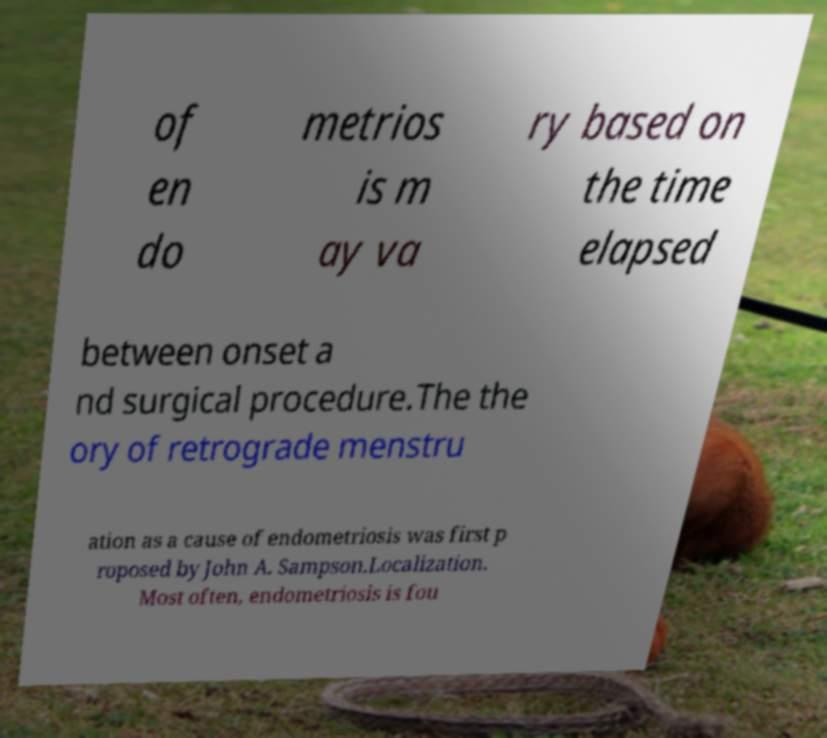I need the written content from this picture converted into text. Can you do that? of en do metrios is m ay va ry based on the time elapsed between onset a nd surgical procedure.The the ory of retrograde menstru ation as a cause of endometriosis was first p roposed by John A. Sampson.Localization. Most often, endometriosis is fou 